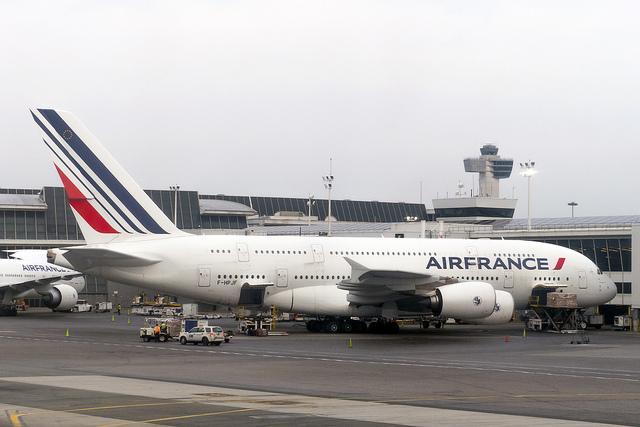Is this plane preparing to land?
Concise answer only. No. What airline does this airplane belong to?
Concise answer only. Air france. Is this at an airport?
Keep it brief. Yes. 